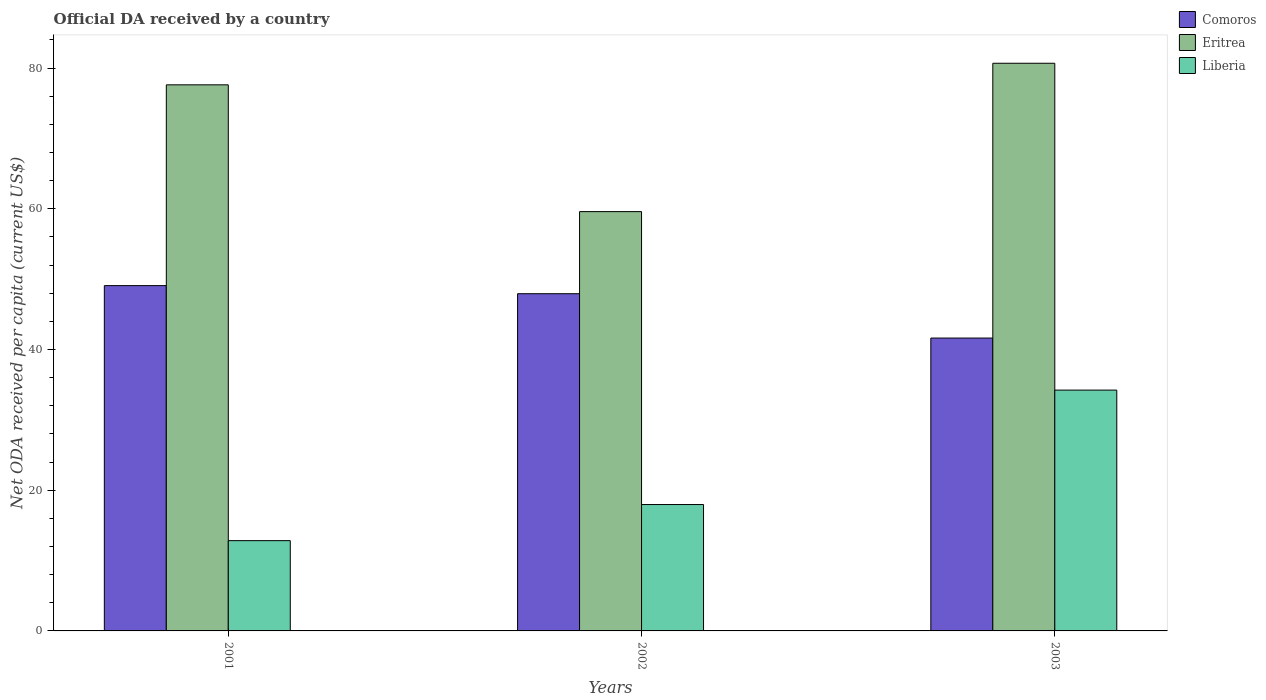How many different coloured bars are there?
Your response must be concise. 3. Are the number of bars per tick equal to the number of legend labels?
Keep it short and to the point. Yes. How many bars are there on the 3rd tick from the left?
Your response must be concise. 3. How many bars are there on the 2nd tick from the right?
Your response must be concise. 3. What is the ODA received in in Comoros in 2002?
Your answer should be very brief. 47.93. Across all years, what is the maximum ODA received in in Eritrea?
Your answer should be compact. 80.69. Across all years, what is the minimum ODA received in in Eritrea?
Ensure brevity in your answer.  59.6. In which year was the ODA received in in Eritrea maximum?
Your answer should be compact. 2003. What is the total ODA received in in Comoros in the graph?
Provide a short and direct response. 138.64. What is the difference between the ODA received in in Eritrea in 2001 and that in 2002?
Your answer should be compact. 18.02. What is the difference between the ODA received in in Eritrea in 2003 and the ODA received in in Comoros in 2002?
Keep it short and to the point. 32.76. What is the average ODA received in in Comoros per year?
Your answer should be compact. 46.21. In the year 2001, what is the difference between the ODA received in in Comoros and ODA received in in Liberia?
Keep it short and to the point. 36.25. In how many years, is the ODA received in in Eritrea greater than 44 US$?
Ensure brevity in your answer.  3. What is the ratio of the ODA received in in Liberia in 2002 to that in 2003?
Your response must be concise. 0.52. Is the ODA received in in Comoros in 2002 less than that in 2003?
Provide a short and direct response. No. Is the difference between the ODA received in in Comoros in 2001 and 2003 greater than the difference between the ODA received in in Liberia in 2001 and 2003?
Provide a short and direct response. Yes. What is the difference between the highest and the second highest ODA received in in Liberia?
Offer a very short reply. 16.27. What is the difference between the highest and the lowest ODA received in in Liberia?
Your answer should be very brief. 21.4. Is the sum of the ODA received in in Liberia in 2001 and 2003 greater than the maximum ODA received in in Eritrea across all years?
Offer a terse response. No. What does the 3rd bar from the left in 2001 represents?
Your response must be concise. Liberia. What does the 3rd bar from the right in 2002 represents?
Provide a succinct answer. Comoros. Is it the case that in every year, the sum of the ODA received in in Comoros and ODA received in in Eritrea is greater than the ODA received in in Liberia?
Provide a succinct answer. Yes. How many years are there in the graph?
Make the answer very short. 3. Are the values on the major ticks of Y-axis written in scientific E-notation?
Offer a very short reply. No. Does the graph contain any zero values?
Offer a very short reply. No. Does the graph contain grids?
Offer a terse response. No. Where does the legend appear in the graph?
Make the answer very short. Top right. How many legend labels are there?
Your response must be concise. 3. What is the title of the graph?
Your response must be concise. Official DA received by a country. Does "Tuvalu" appear as one of the legend labels in the graph?
Give a very brief answer. No. What is the label or title of the X-axis?
Provide a succinct answer. Years. What is the label or title of the Y-axis?
Offer a terse response. Net ODA received per capita (current US$). What is the Net ODA received per capita (current US$) of Comoros in 2001?
Provide a succinct answer. 49.08. What is the Net ODA received per capita (current US$) of Eritrea in 2001?
Ensure brevity in your answer.  77.62. What is the Net ODA received per capita (current US$) of Liberia in 2001?
Keep it short and to the point. 12.83. What is the Net ODA received per capita (current US$) of Comoros in 2002?
Provide a short and direct response. 47.93. What is the Net ODA received per capita (current US$) in Eritrea in 2002?
Your answer should be very brief. 59.6. What is the Net ODA received per capita (current US$) of Liberia in 2002?
Your response must be concise. 17.96. What is the Net ODA received per capita (current US$) in Comoros in 2003?
Offer a very short reply. 41.63. What is the Net ODA received per capita (current US$) in Eritrea in 2003?
Give a very brief answer. 80.69. What is the Net ODA received per capita (current US$) in Liberia in 2003?
Make the answer very short. 34.23. Across all years, what is the maximum Net ODA received per capita (current US$) of Comoros?
Make the answer very short. 49.08. Across all years, what is the maximum Net ODA received per capita (current US$) in Eritrea?
Provide a short and direct response. 80.69. Across all years, what is the maximum Net ODA received per capita (current US$) of Liberia?
Your response must be concise. 34.23. Across all years, what is the minimum Net ODA received per capita (current US$) of Comoros?
Provide a short and direct response. 41.63. Across all years, what is the minimum Net ODA received per capita (current US$) of Eritrea?
Your answer should be very brief. 59.6. Across all years, what is the minimum Net ODA received per capita (current US$) of Liberia?
Give a very brief answer. 12.83. What is the total Net ODA received per capita (current US$) in Comoros in the graph?
Ensure brevity in your answer.  138.64. What is the total Net ODA received per capita (current US$) in Eritrea in the graph?
Your response must be concise. 217.9. What is the total Net ODA received per capita (current US$) of Liberia in the graph?
Offer a terse response. 65.02. What is the difference between the Net ODA received per capita (current US$) in Comoros in 2001 and that in 2002?
Your answer should be compact. 1.15. What is the difference between the Net ODA received per capita (current US$) of Eritrea in 2001 and that in 2002?
Provide a succinct answer. 18.02. What is the difference between the Net ODA received per capita (current US$) in Liberia in 2001 and that in 2002?
Offer a very short reply. -5.13. What is the difference between the Net ODA received per capita (current US$) of Comoros in 2001 and that in 2003?
Offer a very short reply. 7.45. What is the difference between the Net ODA received per capita (current US$) of Eritrea in 2001 and that in 2003?
Your answer should be very brief. -3.07. What is the difference between the Net ODA received per capita (current US$) of Liberia in 2001 and that in 2003?
Give a very brief answer. -21.4. What is the difference between the Net ODA received per capita (current US$) of Comoros in 2002 and that in 2003?
Your answer should be compact. 6.3. What is the difference between the Net ODA received per capita (current US$) of Eritrea in 2002 and that in 2003?
Ensure brevity in your answer.  -21.09. What is the difference between the Net ODA received per capita (current US$) of Liberia in 2002 and that in 2003?
Give a very brief answer. -16.27. What is the difference between the Net ODA received per capita (current US$) in Comoros in 2001 and the Net ODA received per capita (current US$) in Eritrea in 2002?
Your answer should be very brief. -10.52. What is the difference between the Net ODA received per capita (current US$) in Comoros in 2001 and the Net ODA received per capita (current US$) in Liberia in 2002?
Provide a succinct answer. 31.12. What is the difference between the Net ODA received per capita (current US$) of Eritrea in 2001 and the Net ODA received per capita (current US$) of Liberia in 2002?
Your response must be concise. 59.66. What is the difference between the Net ODA received per capita (current US$) in Comoros in 2001 and the Net ODA received per capita (current US$) in Eritrea in 2003?
Ensure brevity in your answer.  -31.61. What is the difference between the Net ODA received per capita (current US$) of Comoros in 2001 and the Net ODA received per capita (current US$) of Liberia in 2003?
Ensure brevity in your answer.  14.85. What is the difference between the Net ODA received per capita (current US$) of Eritrea in 2001 and the Net ODA received per capita (current US$) of Liberia in 2003?
Your answer should be very brief. 43.39. What is the difference between the Net ODA received per capita (current US$) of Comoros in 2002 and the Net ODA received per capita (current US$) of Eritrea in 2003?
Give a very brief answer. -32.76. What is the difference between the Net ODA received per capita (current US$) of Comoros in 2002 and the Net ODA received per capita (current US$) of Liberia in 2003?
Provide a short and direct response. 13.7. What is the difference between the Net ODA received per capita (current US$) in Eritrea in 2002 and the Net ODA received per capita (current US$) in Liberia in 2003?
Offer a very short reply. 25.37. What is the average Net ODA received per capita (current US$) of Comoros per year?
Provide a short and direct response. 46.21. What is the average Net ODA received per capita (current US$) in Eritrea per year?
Provide a short and direct response. 72.63. What is the average Net ODA received per capita (current US$) of Liberia per year?
Your answer should be very brief. 21.67. In the year 2001, what is the difference between the Net ODA received per capita (current US$) of Comoros and Net ODA received per capita (current US$) of Eritrea?
Provide a short and direct response. -28.54. In the year 2001, what is the difference between the Net ODA received per capita (current US$) of Comoros and Net ODA received per capita (current US$) of Liberia?
Ensure brevity in your answer.  36.25. In the year 2001, what is the difference between the Net ODA received per capita (current US$) in Eritrea and Net ODA received per capita (current US$) in Liberia?
Ensure brevity in your answer.  64.79. In the year 2002, what is the difference between the Net ODA received per capita (current US$) in Comoros and Net ODA received per capita (current US$) in Eritrea?
Provide a succinct answer. -11.67. In the year 2002, what is the difference between the Net ODA received per capita (current US$) in Comoros and Net ODA received per capita (current US$) in Liberia?
Your answer should be compact. 29.97. In the year 2002, what is the difference between the Net ODA received per capita (current US$) of Eritrea and Net ODA received per capita (current US$) of Liberia?
Keep it short and to the point. 41.63. In the year 2003, what is the difference between the Net ODA received per capita (current US$) in Comoros and Net ODA received per capita (current US$) in Eritrea?
Provide a short and direct response. -39.06. In the year 2003, what is the difference between the Net ODA received per capita (current US$) of Comoros and Net ODA received per capita (current US$) of Liberia?
Your response must be concise. 7.4. In the year 2003, what is the difference between the Net ODA received per capita (current US$) of Eritrea and Net ODA received per capita (current US$) of Liberia?
Offer a terse response. 46.46. What is the ratio of the Net ODA received per capita (current US$) of Eritrea in 2001 to that in 2002?
Keep it short and to the point. 1.3. What is the ratio of the Net ODA received per capita (current US$) in Comoros in 2001 to that in 2003?
Your answer should be very brief. 1.18. What is the ratio of the Net ODA received per capita (current US$) in Liberia in 2001 to that in 2003?
Give a very brief answer. 0.37. What is the ratio of the Net ODA received per capita (current US$) in Comoros in 2002 to that in 2003?
Your response must be concise. 1.15. What is the ratio of the Net ODA received per capita (current US$) in Eritrea in 2002 to that in 2003?
Offer a terse response. 0.74. What is the ratio of the Net ODA received per capita (current US$) in Liberia in 2002 to that in 2003?
Your answer should be compact. 0.52. What is the difference between the highest and the second highest Net ODA received per capita (current US$) of Comoros?
Make the answer very short. 1.15. What is the difference between the highest and the second highest Net ODA received per capita (current US$) of Eritrea?
Keep it short and to the point. 3.07. What is the difference between the highest and the second highest Net ODA received per capita (current US$) in Liberia?
Offer a terse response. 16.27. What is the difference between the highest and the lowest Net ODA received per capita (current US$) in Comoros?
Offer a terse response. 7.45. What is the difference between the highest and the lowest Net ODA received per capita (current US$) in Eritrea?
Your response must be concise. 21.09. What is the difference between the highest and the lowest Net ODA received per capita (current US$) of Liberia?
Make the answer very short. 21.4. 